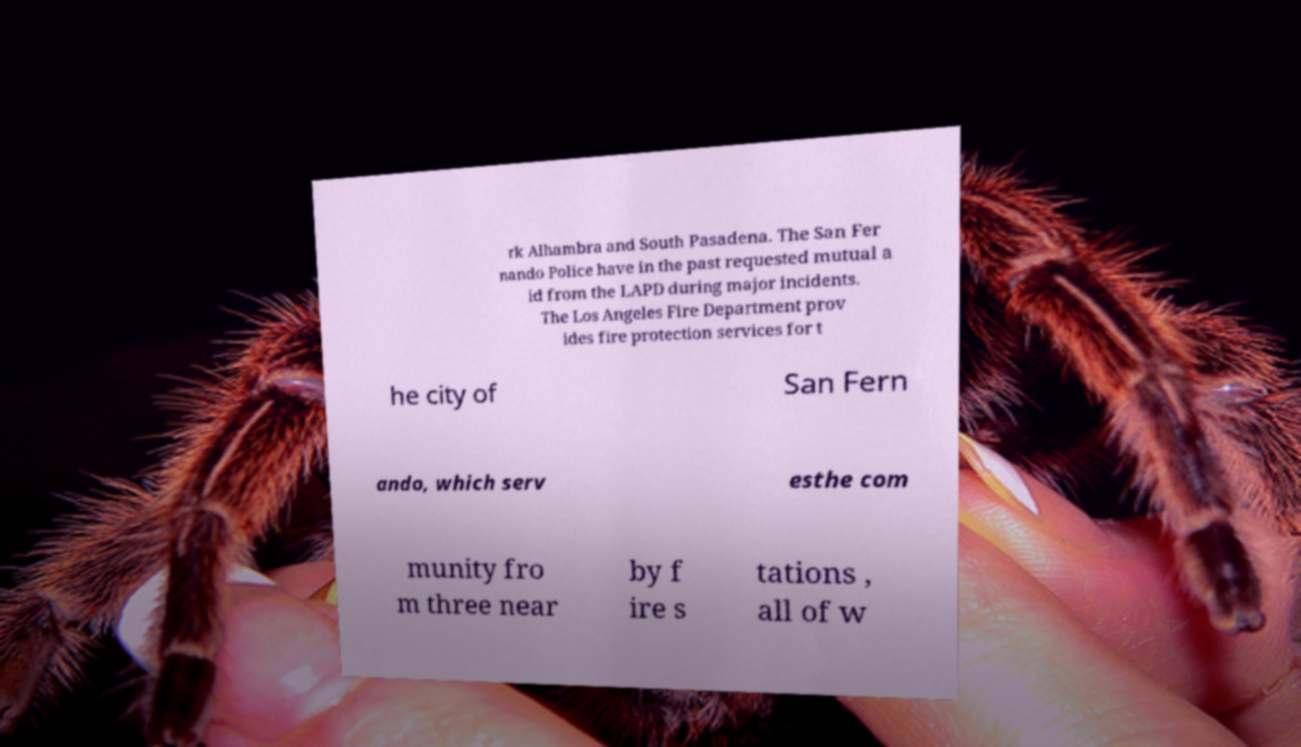Could you assist in decoding the text presented in this image and type it out clearly? rk Alhambra and South Pasadena. The San Fer nando Police have in the past requested mutual a id from the LAPD during major incidents. The Los Angeles Fire Department prov ides fire protection services for t he city of San Fern ando, which serv esthe com munity fro m three near by f ire s tations , all of w 